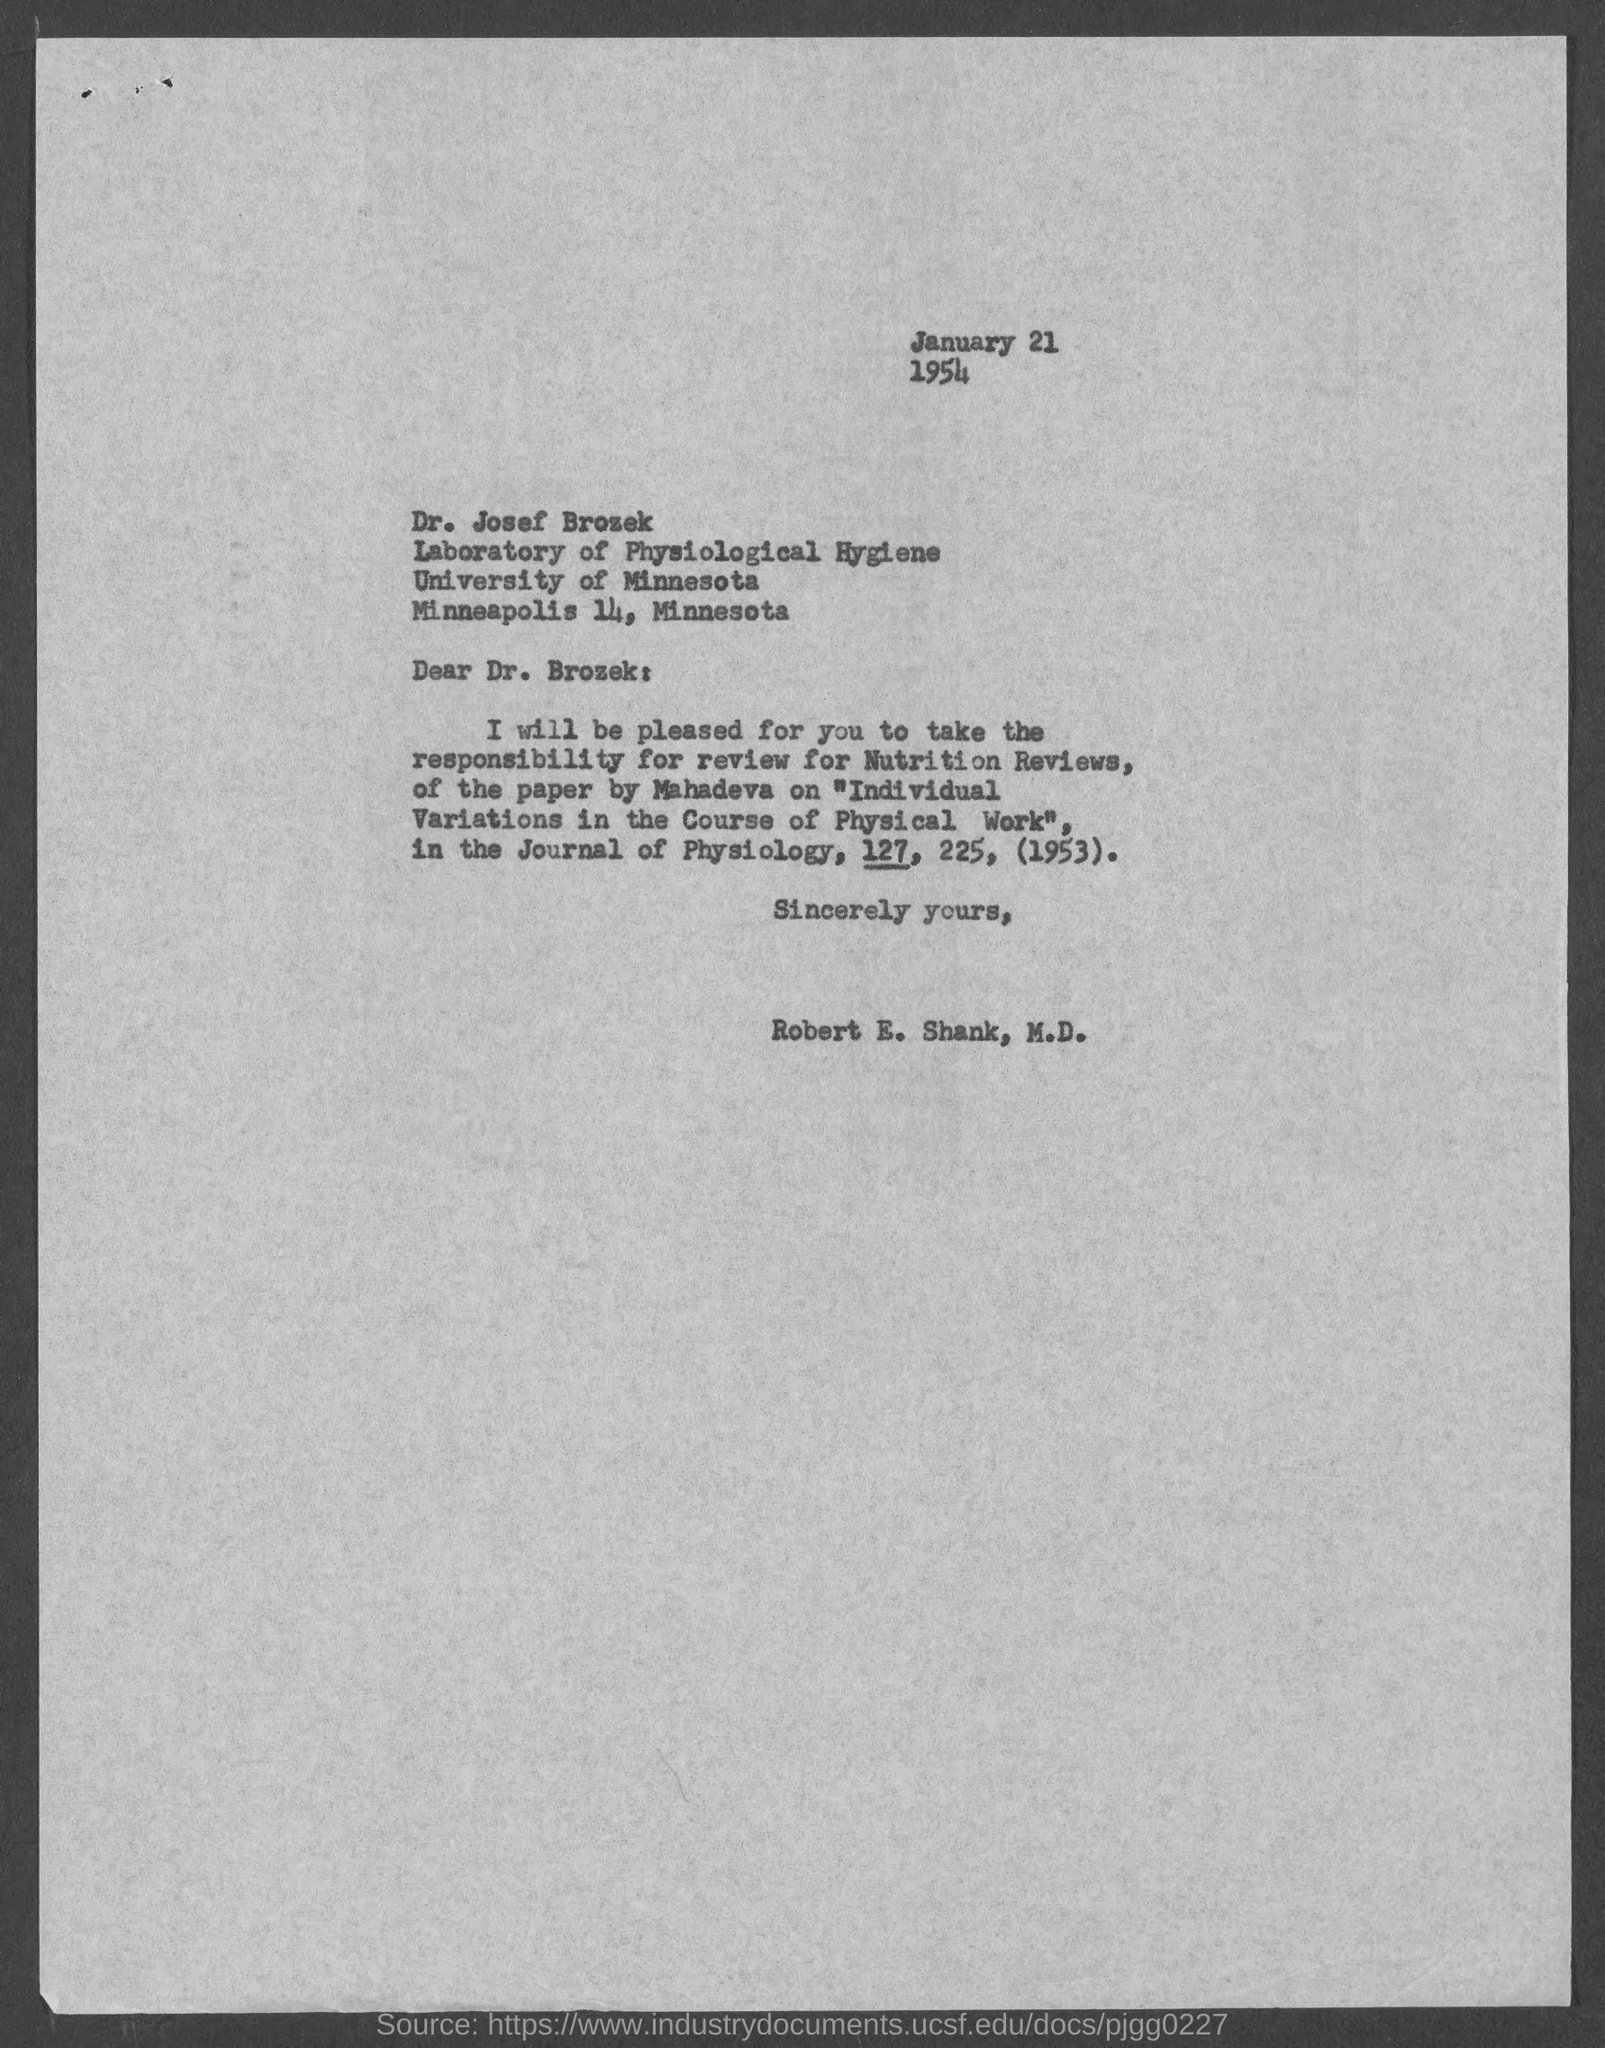When is the document dated?
Give a very brief answer. January 21 1954. To whom is the letter addressed?
Your response must be concise. Dr. Josef Brozek. Which is the paper by Mahadeva?
Keep it short and to the point. Individual Variations in the Course of Physical Work. 